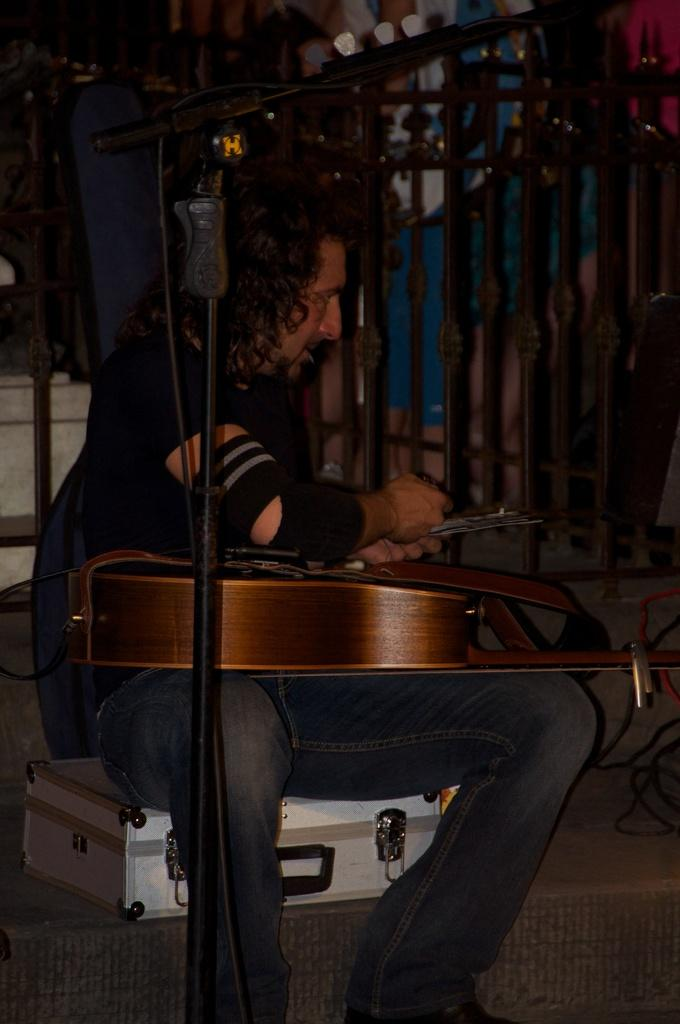What is the man in the image doing? The man is sitting on a suitcase and holding a guitar. What object is the man holding in the image? The man is holding a guitar. What other object is present in the image related to music? There is a microphone in the image. What can be seen in the background of the image? There is a fence in the image. What type of washing machine is visible in the image? There is no washing machine present in the image. What subject is the man teaching in the image? The image does not depict the man teaching any subject. 